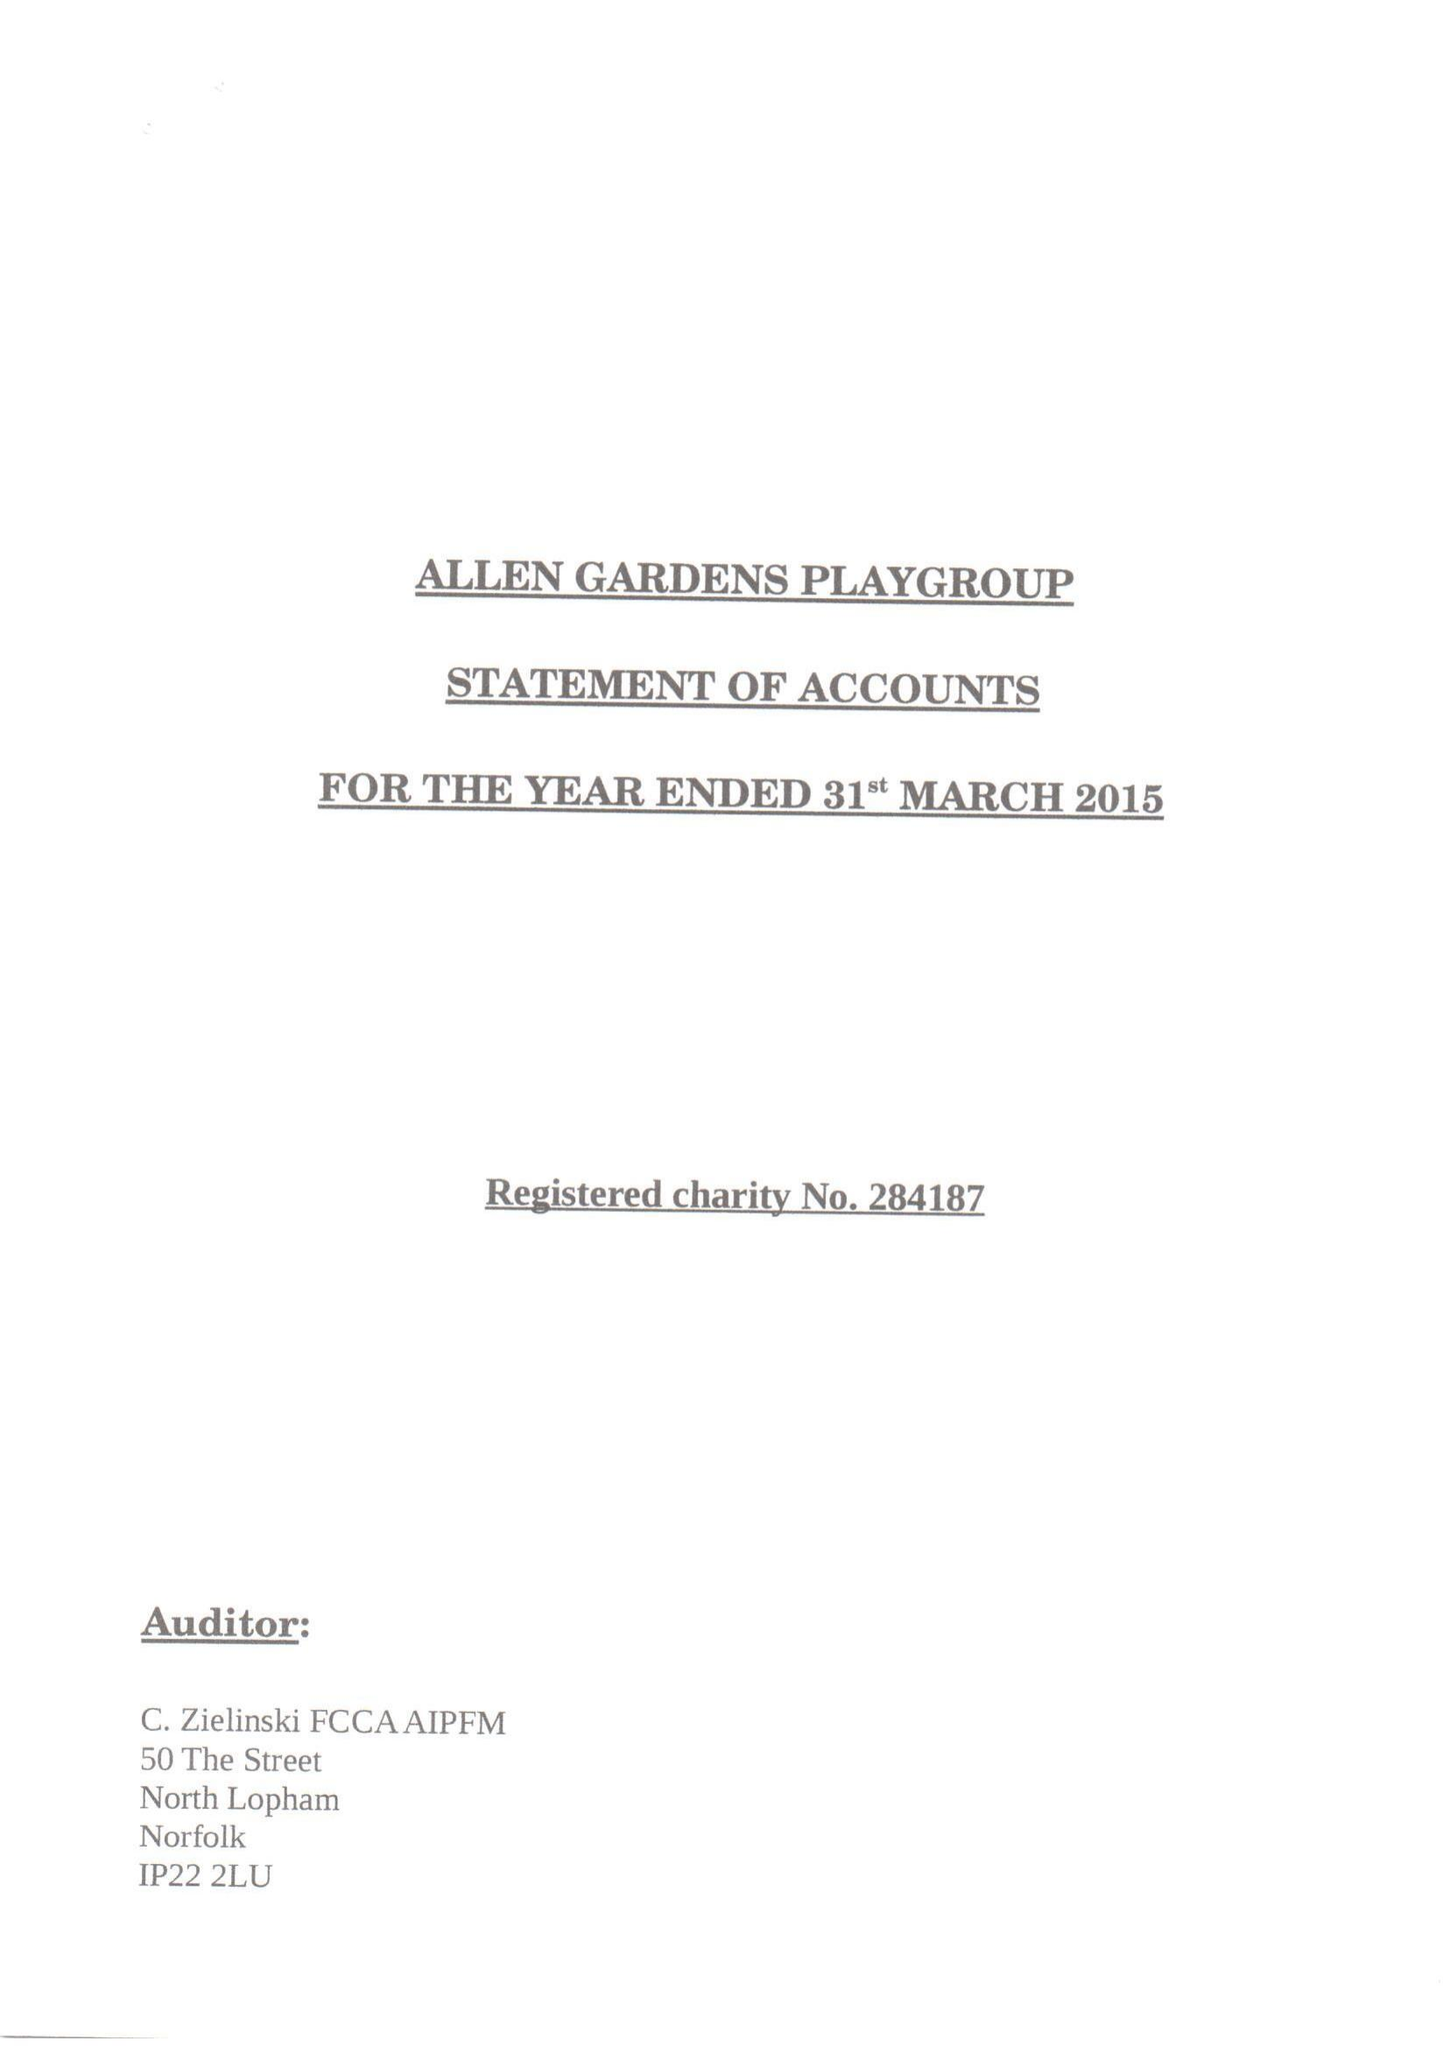What is the value for the spending_annually_in_british_pounds?
Answer the question using a single word or phrase. 62754.00 